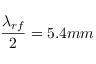<formula> <loc_0><loc_0><loc_500><loc_500>\frac { \lambda _ { r f } } { 2 } = 5 . 4 m m</formula> 